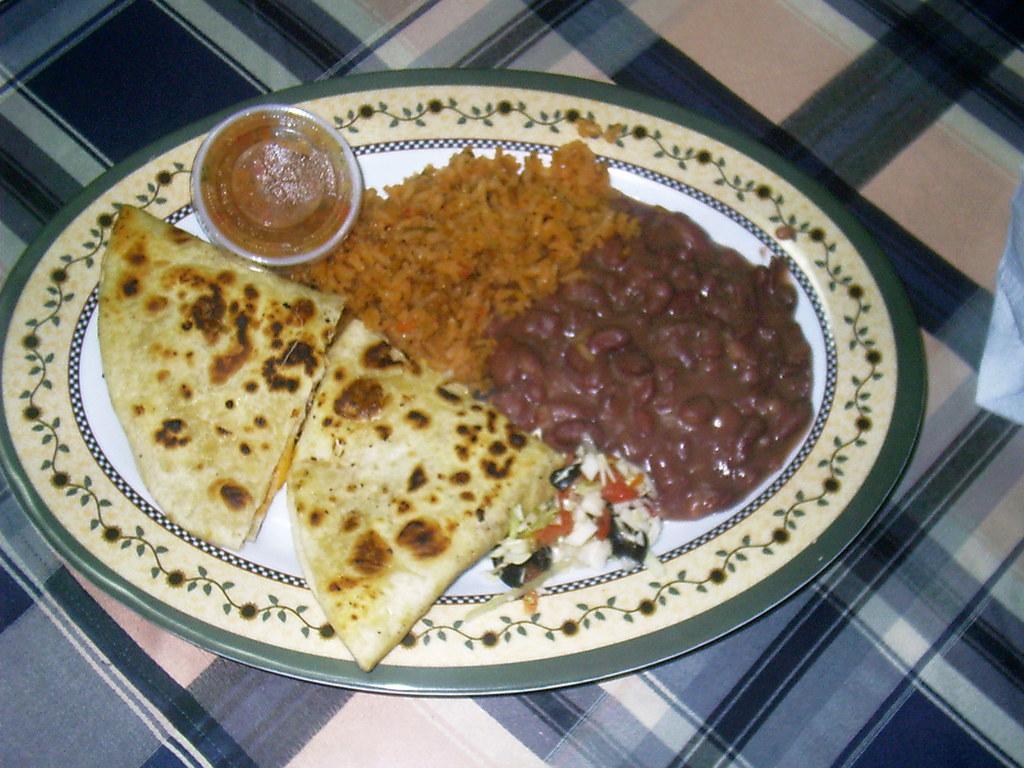In one or two sentences, can you explain what this image depicts? In this picture I can see food items and a tiny plastic box with a lid on the plate, on the cloth. 